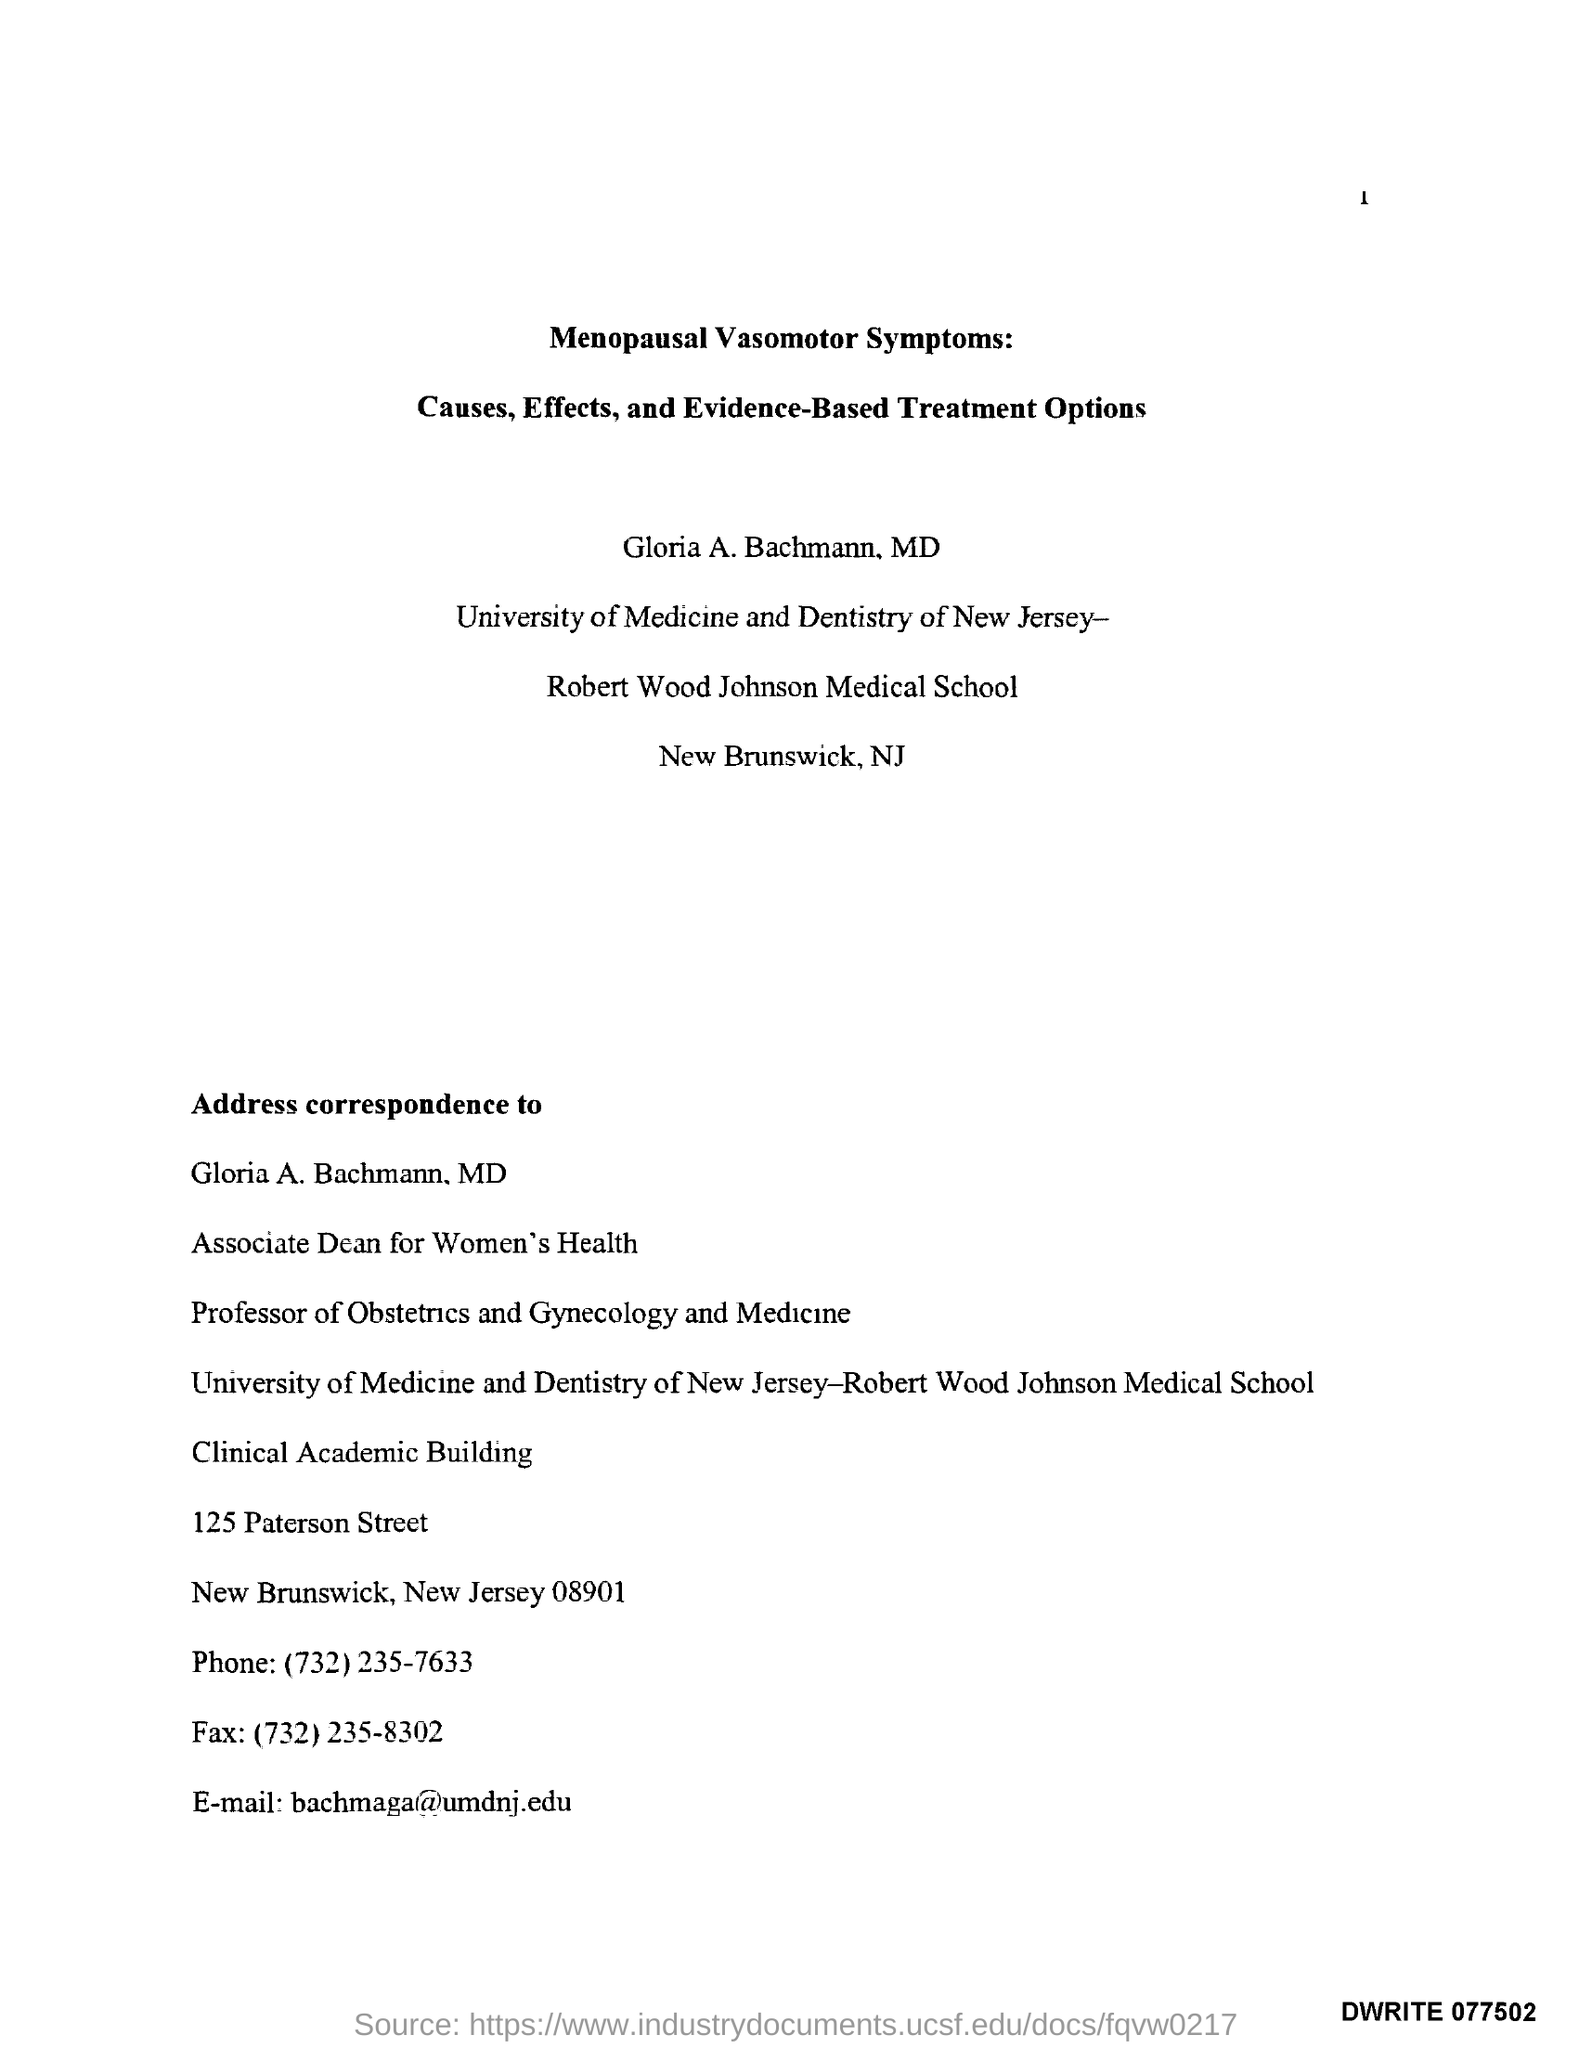What is the phone number mentioned ?
Provide a short and direct response. (732)235-7633. What is the name of the street mentioned in the address to correspondence ?
Make the answer very short. Paterson Street. What is the fax no ?
Give a very brief answer. (732)235-8302. What is the email mentioned ?
Offer a very short reply. Bachmaga@umdnj.edu. What is the name of the building for address correspondence ?
Your response must be concise. Clinical academic building. What is the name of the university ?
Offer a very short reply. University of medicine and dentistry of New Jersey - Robert Wood Johnson Medical School. What is the name of the medical school ?
Your answer should be very brief. Robert Wood Johnson Medical School. 